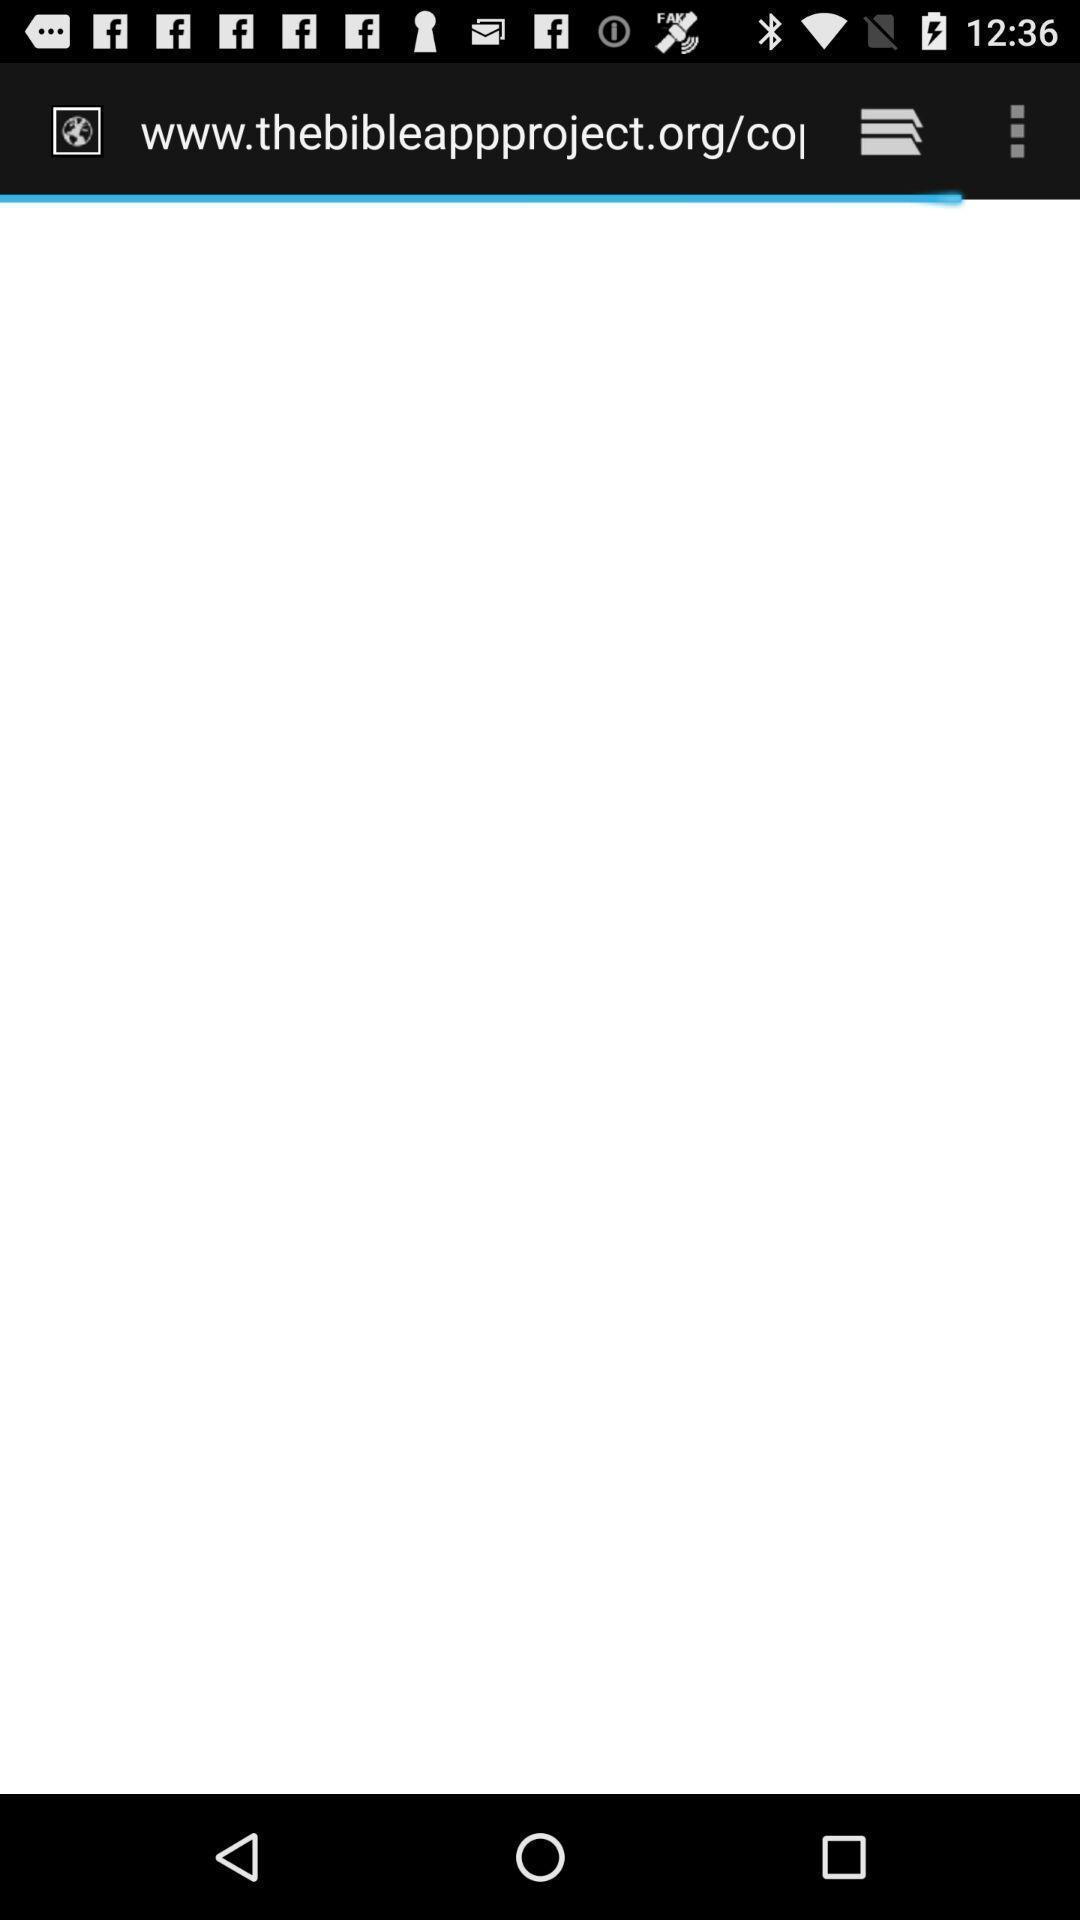What is the overall content of this screenshot? Page to read the bible. 